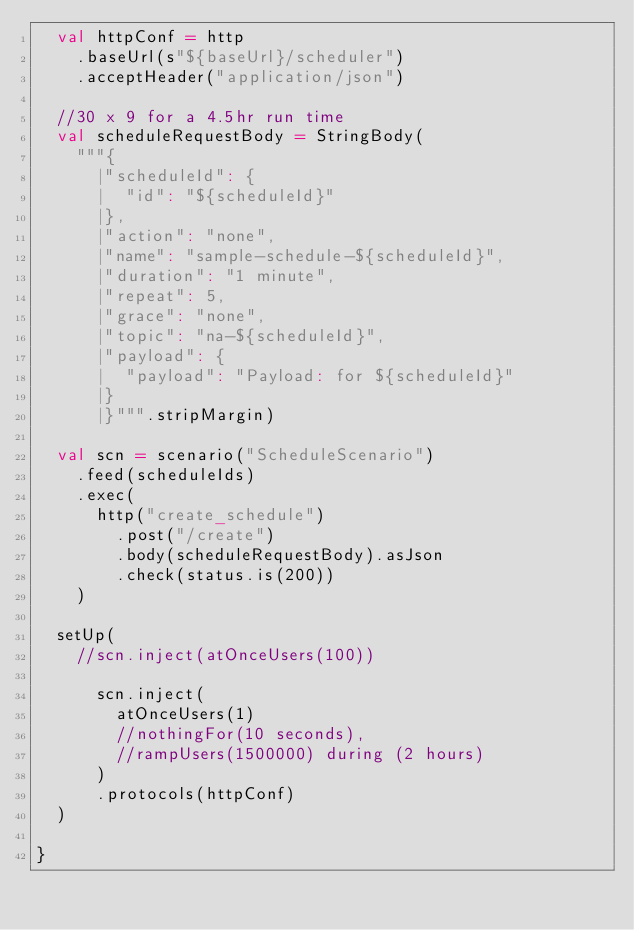Convert code to text. <code><loc_0><loc_0><loc_500><loc_500><_Scala_>  val httpConf = http
    .baseUrl(s"${baseUrl}/scheduler")
    .acceptHeader("application/json")

  //30 x 9 for a 4.5hr run time
  val scheduleRequestBody = StringBody(
    """{
      |"scheduleId": {
      |  "id": "${scheduleId}"
      |},
      |"action": "none",
      |"name": "sample-schedule-${scheduleId}",
      |"duration": "1 minute",
      |"repeat": 5,
      |"grace": "none",
      |"topic": "na-${scheduleId}",
      |"payload": {
      |  "payload": "Payload: for ${scheduleId}"
      |}
      |}""".stripMargin)

  val scn = scenario("ScheduleScenario")
    .feed(scheduleIds)
    .exec(
      http("create_schedule")
        .post("/create")
        .body(scheduleRequestBody).asJson
        .check(status.is(200))
    )

  setUp(
    //scn.inject(atOnceUsers(100))

      scn.inject(
        atOnceUsers(1)
        //nothingFor(10 seconds),
        //rampUsers(1500000) during (2 hours)
      )
      .protocols(httpConf)
  )

}</code> 